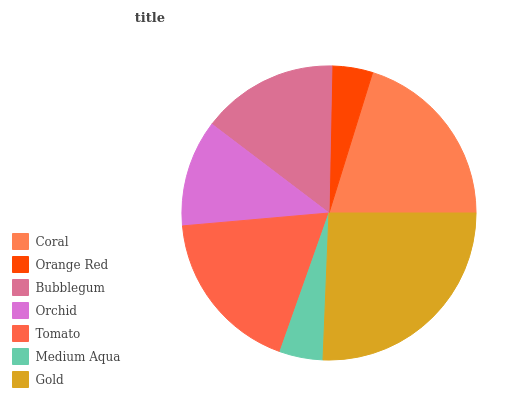Is Orange Red the minimum?
Answer yes or no. Yes. Is Gold the maximum?
Answer yes or no. Yes. Is Bubblegum the minimum?
Answer yes or no. No. Is Bubblegum the maximum?
Answer yes or no. No. Is Bubblegum greater than Orange Red?
Answer yes or no. Yes. Is Orange Red less than Bubblegum?
Answer yes or no. Yes. Is Orange Red greater than Bubblegum?
Answer yes or no. No. Is Bubblegum less than Orange Red?
Answer yes or no. No. Is Bubblegum the high median?
Answer yes or no. Yes. Is Bubblegum the low median?
Answer yes or no. Yes. Is Coral the high median?
Answer yes or no. No. Is Orchid the low median?
Answer yes or no. No. 